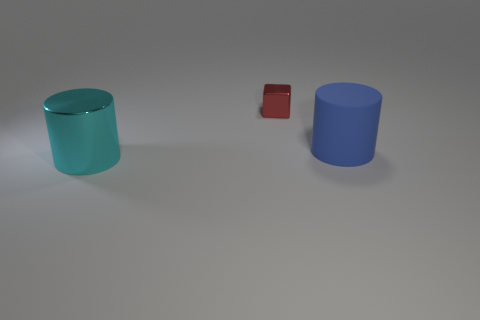Is there anything else that has the same size as the red metal block?
Ensure brevity in your answer.  No. The cyan object has what shape?
Make the answer very short. Cylinder. There is a large thing behind the cylinder on the left side of the large rubber thing; what shape is it?
Keep it short and to the point. Cylinder. Is the material of the thing that is on the right side of the shiny block the same as the cyan cylinder?
Provide a short and direct response. No. How many blue things are either big rubber cylinders or big things?
Ensure brevity in your answer.  1. Are there any small matte cylinders of the same color as the small thing?
Offer a very short reply. No. Are there any blue cylinders made of the same material as the tiny cube?
Your response must be concise. No. There is a thing that is both to the right of the metal cylinder and in front of the tiny cube; what shape is it?
Provide a succinct answer. Cylinder. How many small things are blue rubber balls or shiny cylinders?
Provide a succinct answer. 0. What material is the small red object?
Offer a terse response. Metal. 